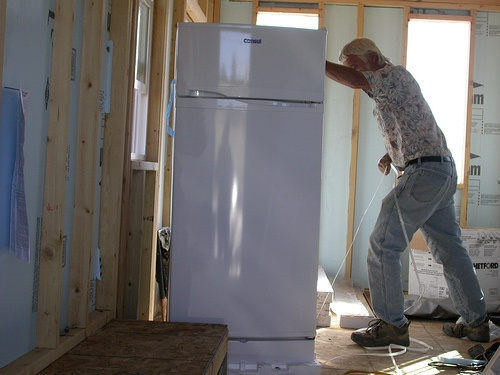Describe the objects in this image and their specific colors. I can see refrigerator in gray and black tones and people in gray, black, and darkgray tones in this image. 